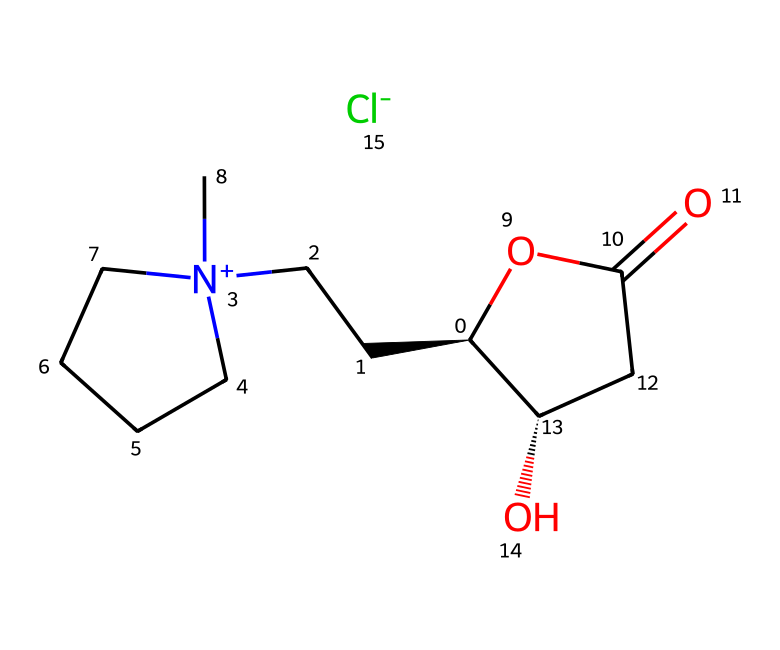What is the total number of carbon atoms in this ionic liquid? By examining the SMILES representation, we can count the number of carbon atoms present. The structure includes the backbone where 'C' represents carbon atoms, which can be counted through the entire formula, totaling 12.
Answer: 12 How many distinct functional groups are present in this compound? In the SMILES representation, we can identify distinct functional groups. The carboxylate group (OC(=O)) and hydroxyl group (C[C@@H]1O) suggest there are two distinct functional groups.
Answer: 2 What type of ionic species does this compound contain? The presence of '[Cl-]' indicates the presence of chloride ion, which classifies this compound's ionic species as a chloride salt.
Answer: chloride What is the significance of the chirality indicated in the SMILES? The '@' symbol indicates chirality in the chemical structure. The presence of chiral centers suggests that the ionic liquid may exhibit different properties based on its stereochemistry, such as solubility, which is essential in food preservation contexts.
Answer: chirality Does this ionic liquid potentially offer antimicrobial properties? Given the structure, it may contain functional domains that could interact with microbial membranes, suggesting potential antimicrobial properties. However, further analysis is required for concrete claims.
Answer: yes What type of reaction mechanisms could this ionic liquid be involved in with food preservation? The functional groups present may allow for esterification or solubilization reactions, enabling interactions with food components to enhance preservation efficacy.
Answer: esterification 